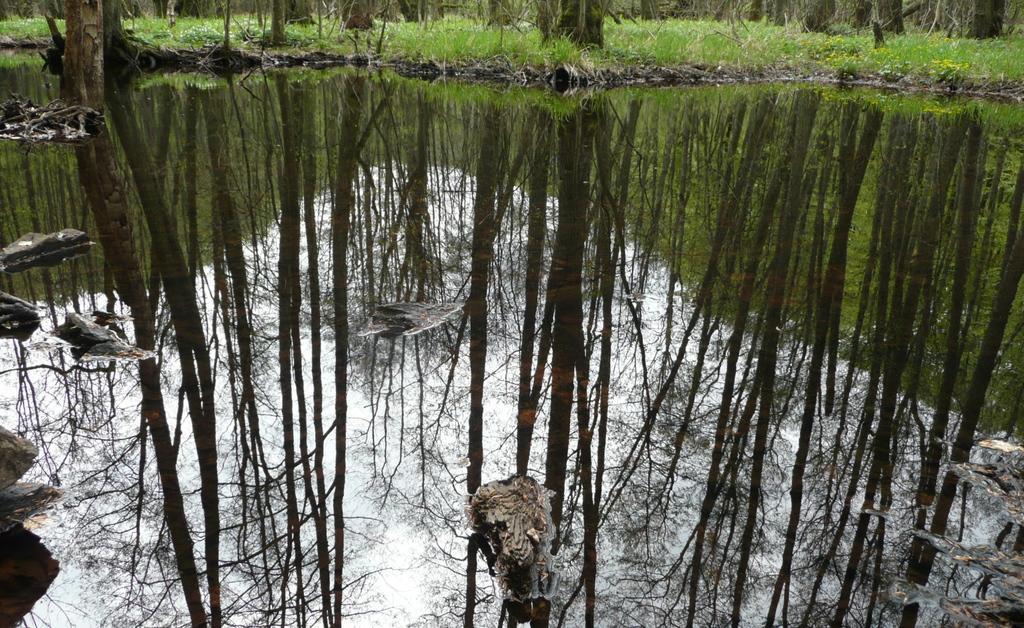Please provide a concise description of this image. In the image there is a pond in the front and in the back there are many trees on the grassland. 